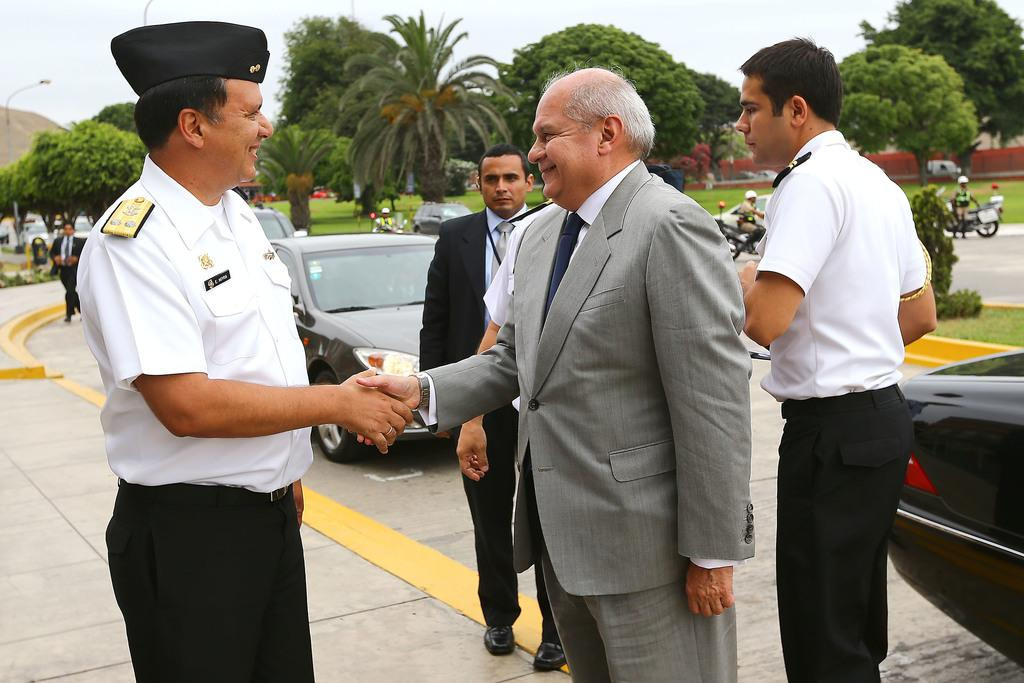What can be seen at the bottom of the image? There is a group of persons standing at the bottom of the image. What type of vehicles are visible in the background of the image? There are cars and other vehicles in the background of the image. What other elements can be seen in the background of the image? There are trees in the background of the image. What is visible at the top of the image? The sky is visible at the top of the image. What type of school can be seen in the image? There is no school present in the image. How does the door in the image change its appearance? There is no door present in the image. 